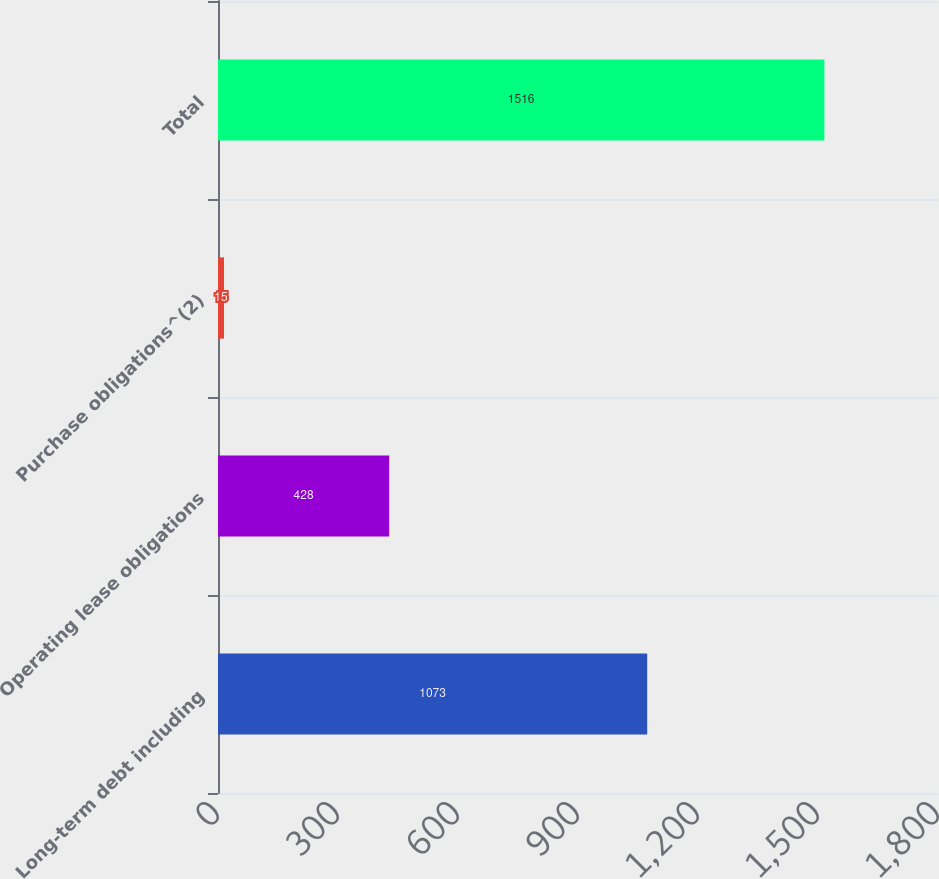<chart> <loc_0><loc_0><loc_500><loc_500><bar_chart><fcel>Long-term debt including<fcel>Operating lease obligations<fcel>Purchase obligations^(2)<fcel>Total<nl><fcel>1073<fcel>428<fcel>15<fcel>1516<nl></chart> 